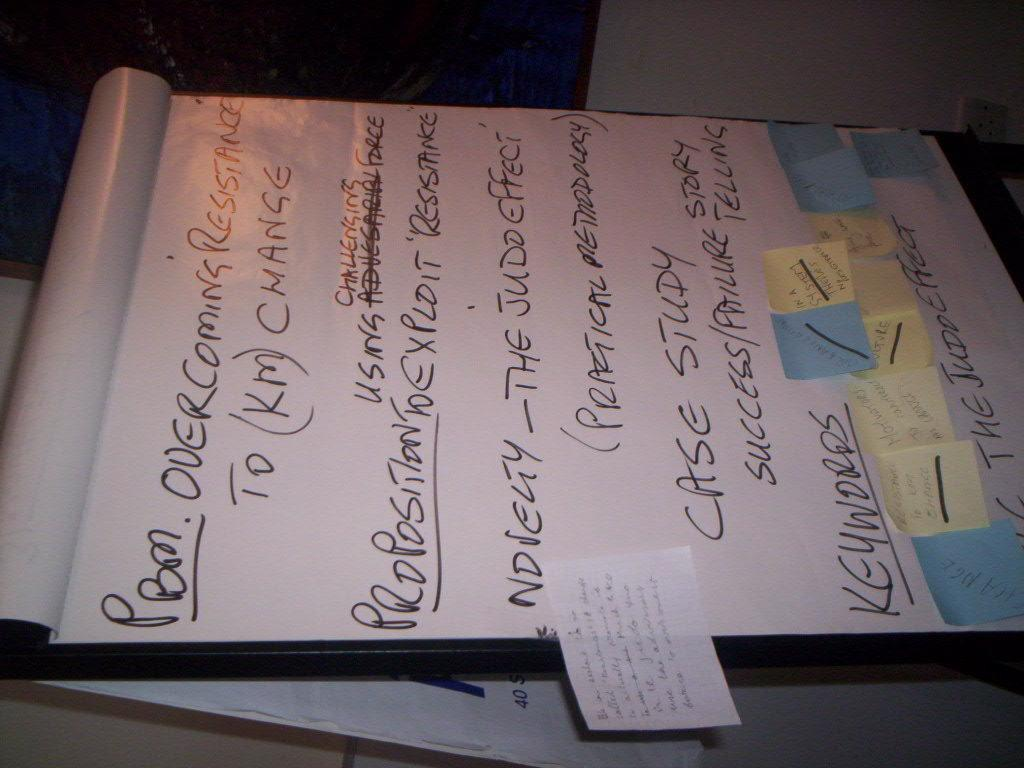<image>
Render a clear and concise summary of the photo. A handwritten list with items like overcoming resistance. 